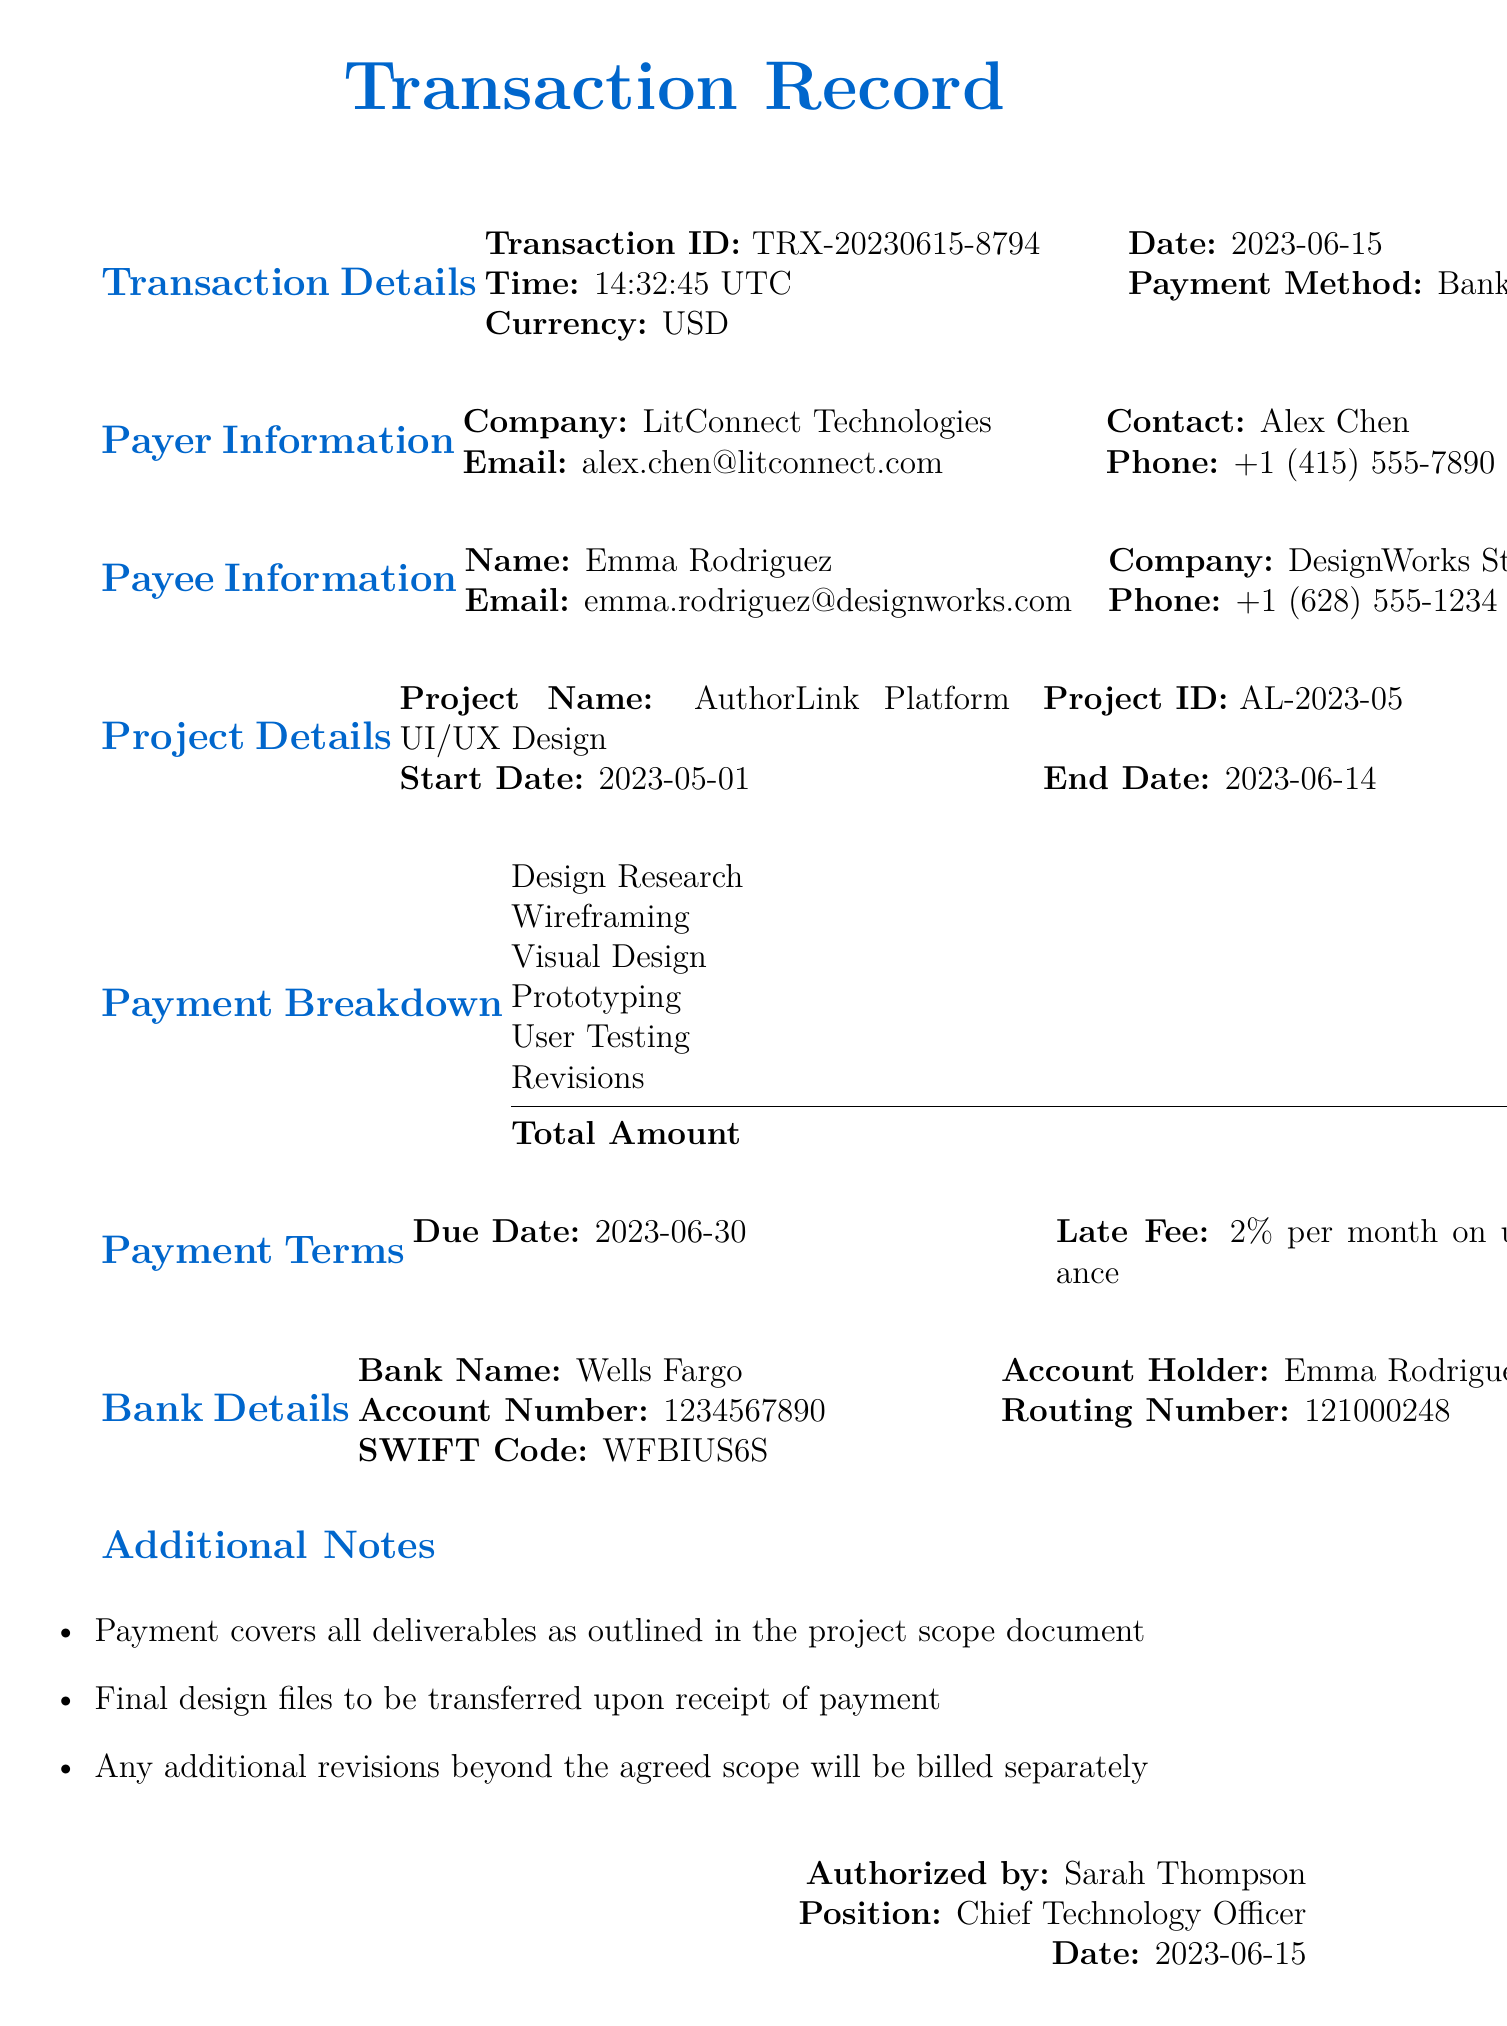What is the transaction ID? The transaction ID is specified in the transaction details section of the document as TRX-20230615-8794.
Answer: TRX-20230615-8794 Who is the contact person for the payer? The document lists Alex Chen as the contact person for LitConnect Technologies, the payer.
Answer: Alex Chen What is the total amount due? The total amount due is highlighted in the payment breakdown section as $17,000.
Answer: $17,000 What is the due date for payment? The due date for payment is mentioned in the payment terms section as 2023-06-30.
Answer: 2023-06-30 How much is the late fee per month? The document states that the late fee is 2% per month on unpaid balance.
Answer: 2% per month What is the project name? The project name is clearly stated in the project details section as AuthorLink Platform UI/UX Design.
Answer: AuthorLink Platform UI/UX Design Who is the authorized person for this transaction? The document indicates that Sarah Thompson is the authorized person for this transaction.
Answer: Sarah Thompson What payment method was used? The payment method is specified in the transaction details section as Bank Transfer.
Answer: Bank Transfer What is the SWIFT code for the bank? The bank's SWIFT code is provided in the bank details section as WFBIUS6S.
Answer: WFBIUS6S 